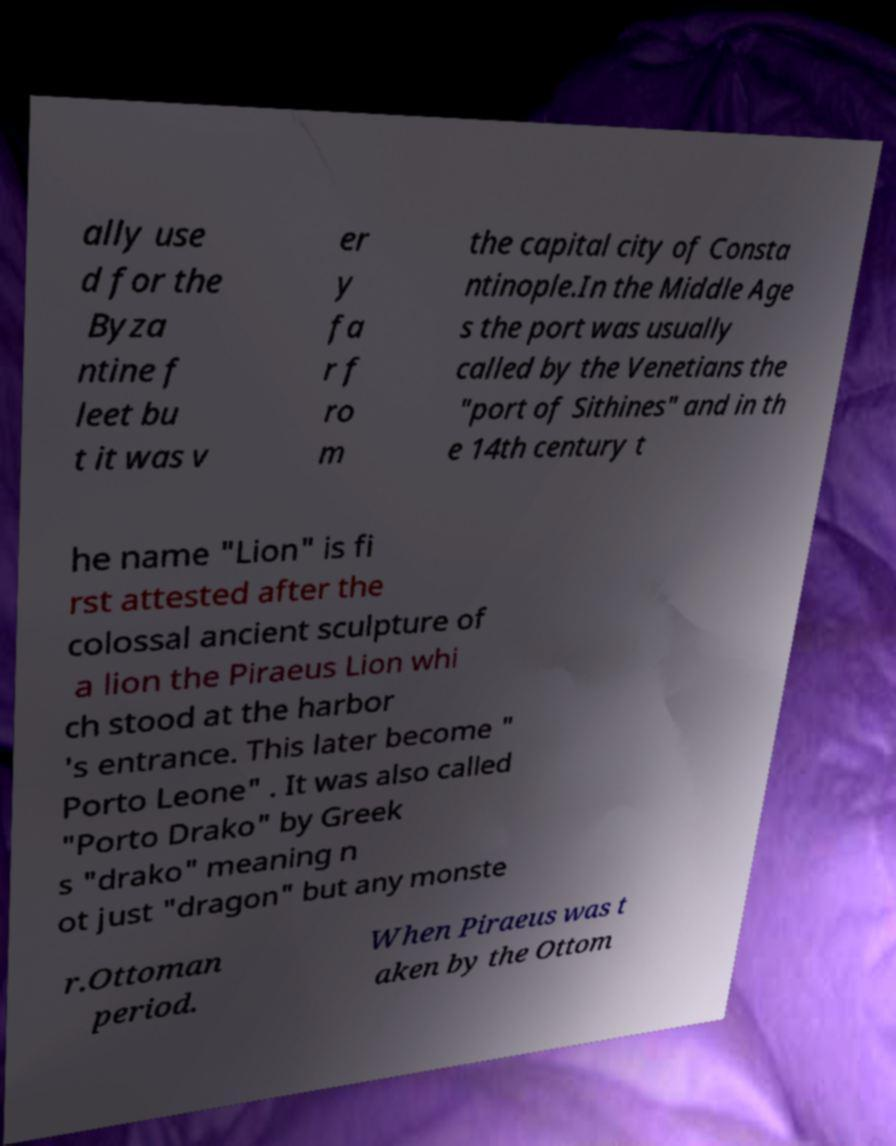I need the written content from this picture converted into text. Can you do that? ally use d for the Byza ntine f leet bu t it was v er y fa r f ro m the capital city of Consta ntinople.In the Middle Age s the port was usually called by the Venetians the "port of Sithines" and in th e 14th century t he name "Lion" is fi rst attested after the colossal ancient sculpture of a lion the Piraeus Lion whi ch stood at the harbor 's entrance. This later become " Porto Leone" . It was also called "Porto Drako" by Greek s "drako" meaning n ot just "dragon" but any monste r.Ottoman period. When Piraeus was t aken by the Ottom 